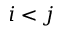<formula> <loc_0><loc_0><loc_500><loc_500>i < j</formula> 